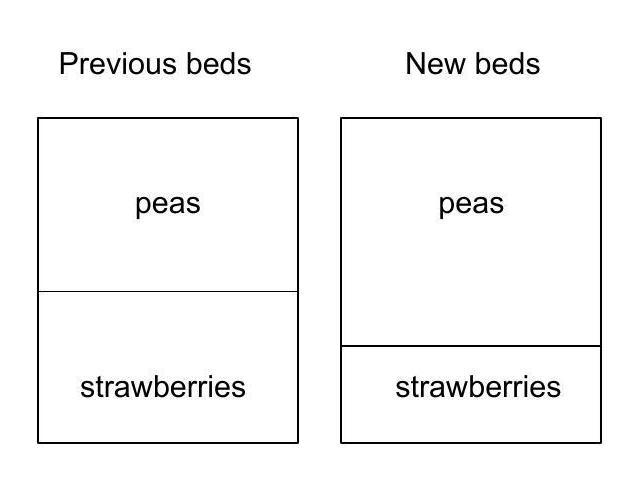How did the shape of the pea bed change after Mrs. Gardner moved the boundary? After moving the boundary, Mrs. Gardner altered the pea bed from a rectangle to a square, by extending one of the sides by 3 meters. This adjustment to the boundary created a uniform length on all sides of the bed dedicated to the peas. What implications might this have for her planting strategy? The transformation of the pea bed to a square shape could impact Mrs. Gardner's planting strategy by potentially simplifying planting layout due to the regular shape, allowing for more efficient irrigation and maintenance due to the equal-length sides. Additionally, the square shape could make it easier to calculate seed requirements and optimize the use of space. 